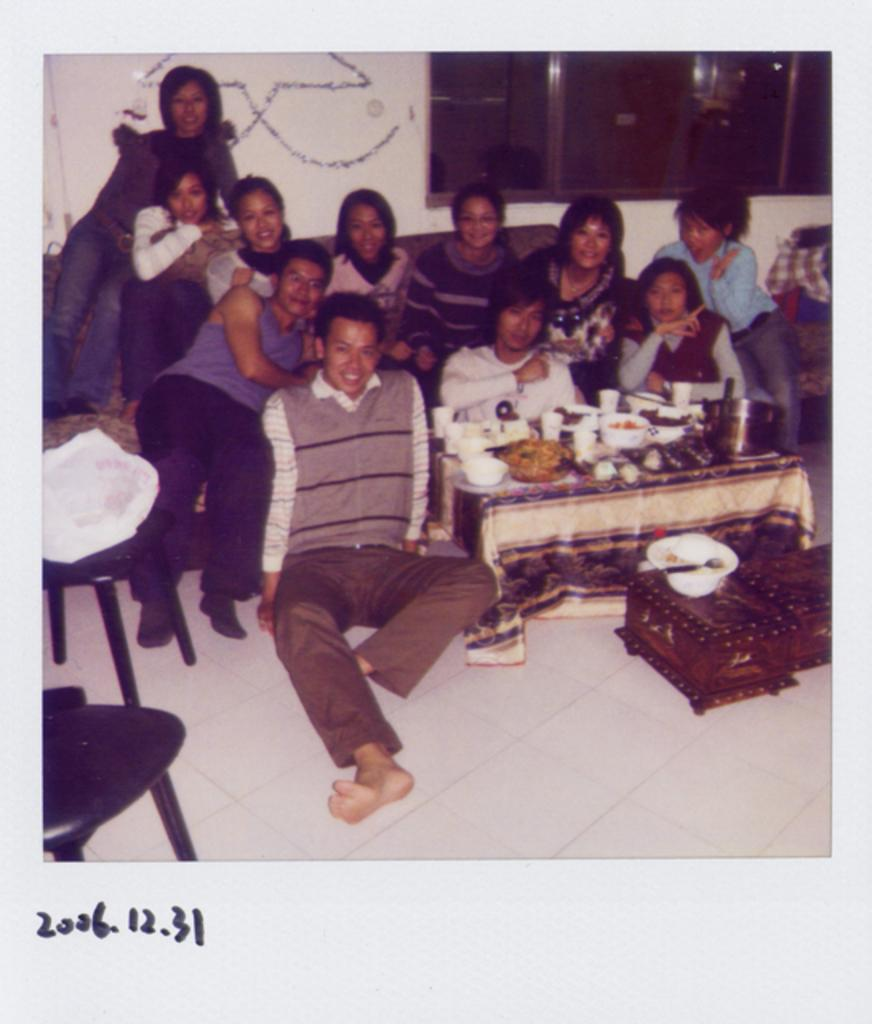How many people are in the image? There is a group of people in the image, but the exact number is not specified. What are the people doing in the image? Some people are seated on a sofa, and some are seated on the floor. What objects are on the table in the image? There are bowls and glasses on the table. What type of pancake is being served in the image? There is no pancake present in the image. What language are the people speaking in the image? The language being spoken by the people in the image is not specified. 